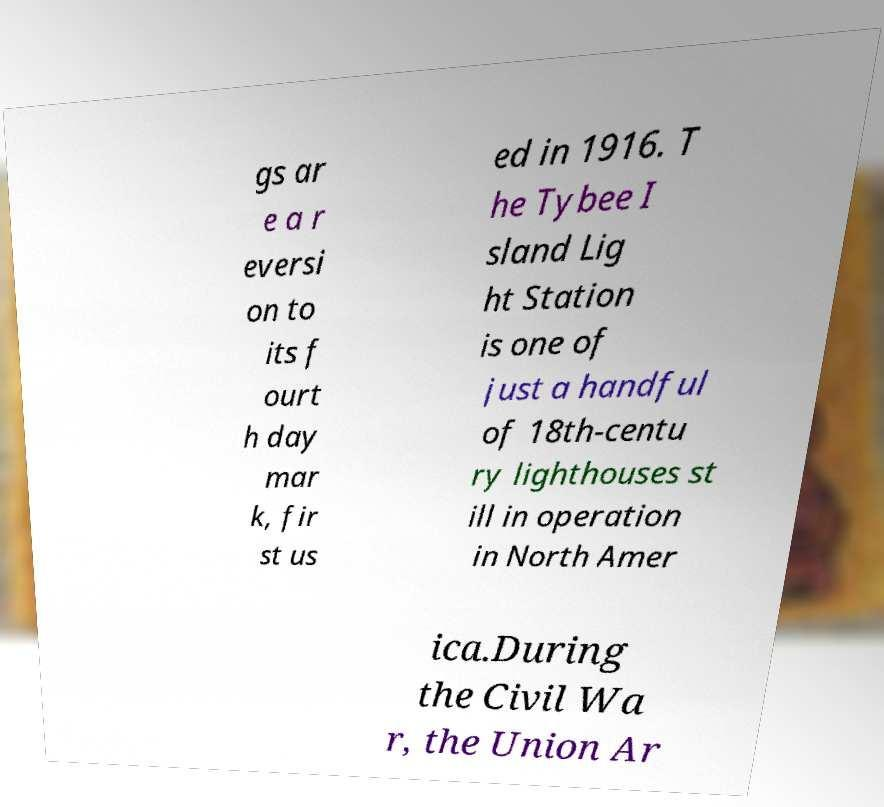For documentation purposes, I need the text within this image transcribed. Could you provide that? gs ar e a r eversi on to its f ourt h day mar k, fir st us ed in 1916. T he Tybee I sland Lig ht Station is one of just a handful of 18th-centu ry lighthouses st ill in operation in North Amer ica.During the Civil Wa r, the Union Ar 